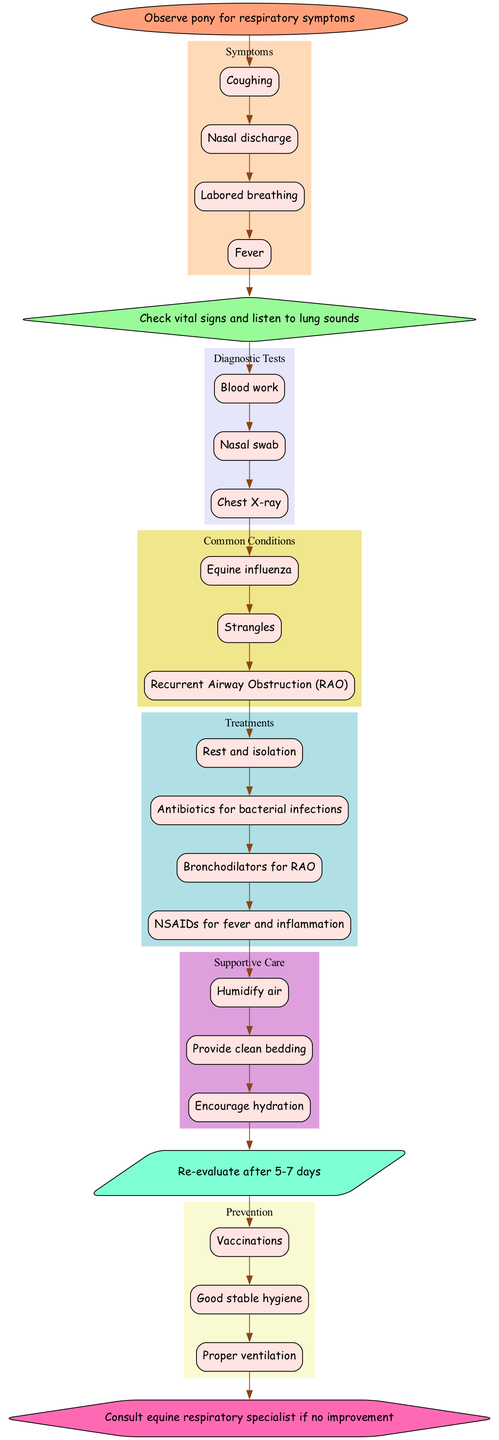what is the first step in the diagram? The first step is to "Observe pony for respiratory symptoms," which is indicated in the start node of the diagram.
Answer: Observe pony for respiratory symptoms how many respiratory symptoms are listed in the diagram? The diagram lists four symptoms: Coughing, Nasal discharge, Labored breathing, and Fever. This can be counted from the symptoms subgraph.
Answer: 4 which diagnostic test comes after checking vital signs? After checking vital signs and listening to lung sounds (initial assessment), the next step is to conduct "Blood work," as it is the first diagnostic test listed in the diagram.
Answer: Blood work what are two treatments indicated for common pony respiratory issues? The treatments included in the diagram are "Rest and isolation" and "Antibiotics for bacterial infections," among others. This information can be found in the treatments subgraph.
Answer: Rest and isolation, Antibiotics for bacterial infections if a pony shows no improvement after treatment, what step should be taken? If there is no improvement after treatment, the diagram instructs to "Consult equine respiratory specialist," which is the referral step indicated in the diagram.
Answer: Consult equine respiratory specialist which supportive care option focuses on pony comfort? "Humidify air" is a supportive care option that is specifically aimed at making the pony more comfortable by ensuring a better breathing environment. This information is found in the supportive care subgraph.
Answer: Humidify air how many conditions are categorized as common conditions in the diagram? There are three common conditions listed: Equine influenza, Strangles, and Recurrent Airway Obstruction (RAO). This can be counted from the common conditions subgraph.
Answer: 3 what is recommended as part of follow-up care? The diagram recommends to "Re-evaluate after 5-7 days," indicating a recommended follow-up care step after initial treatment.
Answer: Re-evaluate after 5-7 days what is a measure included in the prevention section? "Vaccinations" is one of the prevention measures included in the diagram, which is aimed at preventing respiratory issues in ponies.
Answer: Vaccinations 